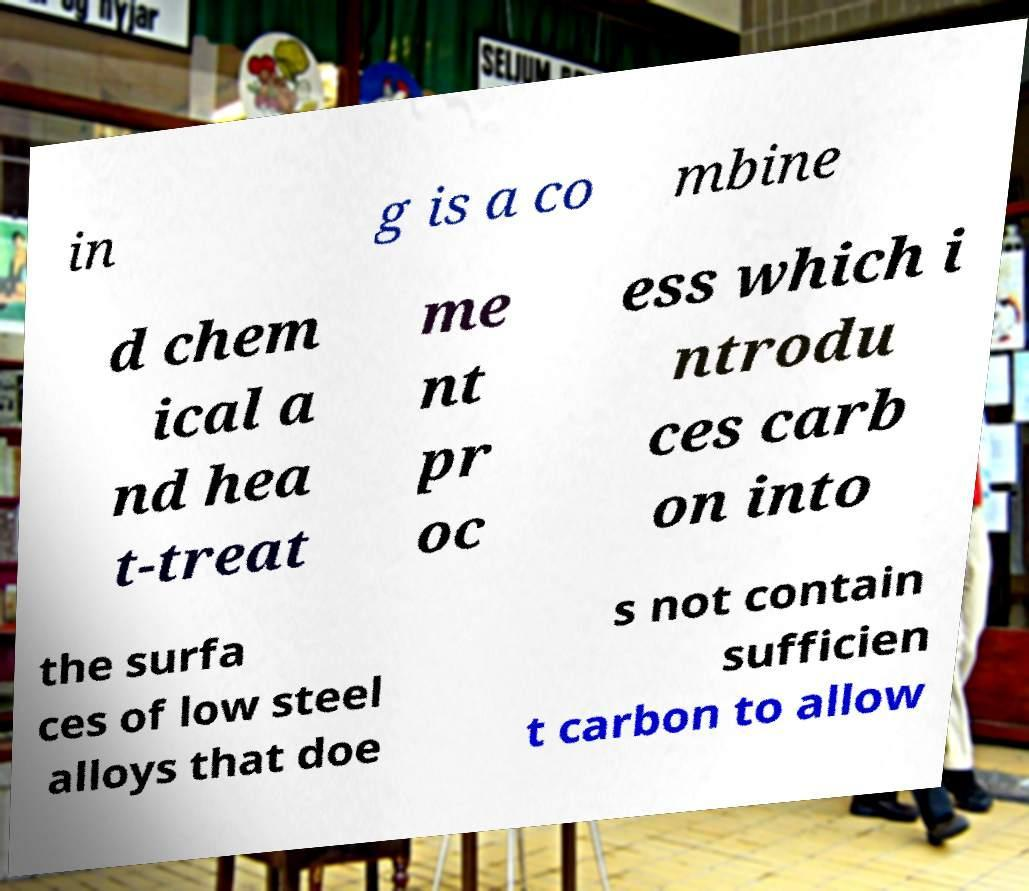What messages or text are displayed in this image? I need them in a readable, typed format. in g is a co mbine d chem ical a nd hea t-treat me nt pr oc ess which i ntrodu ces carb on into the surfa ces of low steel alloys that doe s not contain sufficien t carbon to allow 